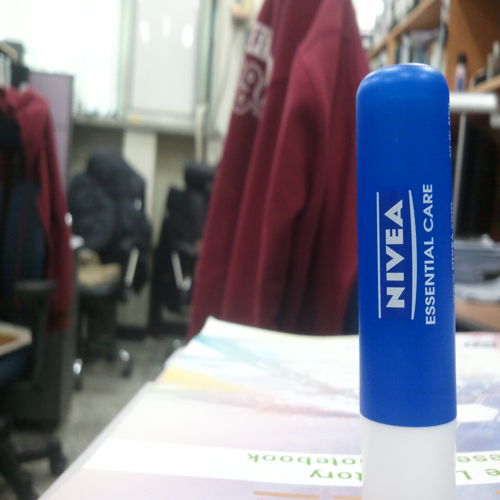Are the texture details of the main subject well preserved? The texture details of the Nivea Essential Care lip balm are sharply captured, clearly showing the fine text and smooth finish of the label, as well as the characteristic blue and white colors of the brand. The focus on the lip balm allows for a distinct foreground against the softly blurred background, making the subject prominent. 